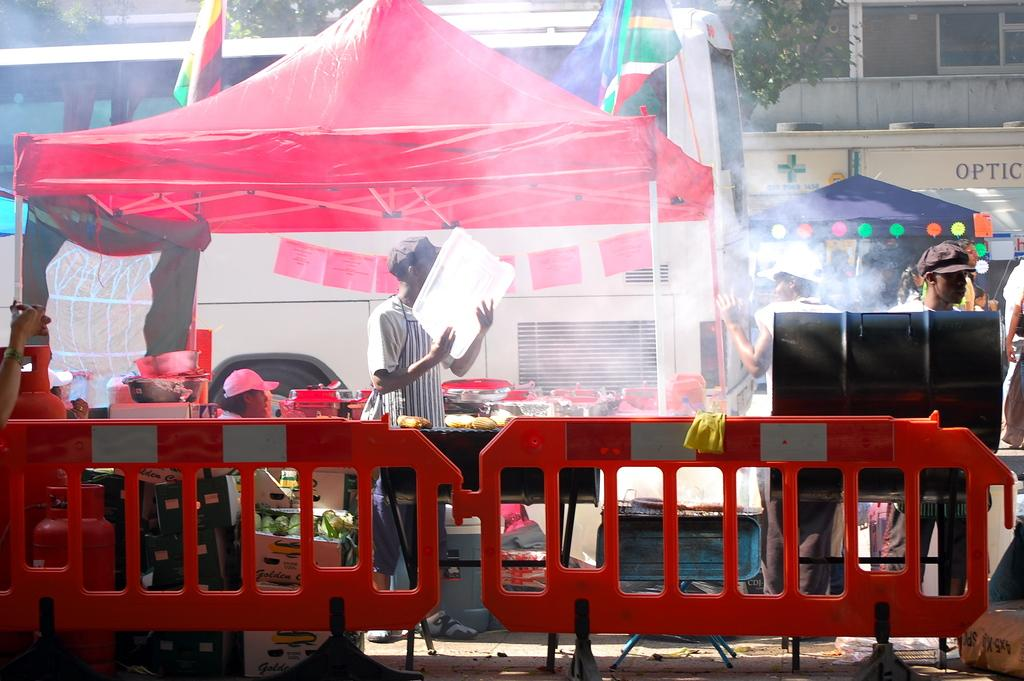What are the people in the image doing under the tents? The image shows people under tents, but their specific activity is not mentioned in the facts. What type of furniture is present in the image? There are tables in the image. What objects can be seen in addition to the tables? There are boxes and vessels in the image. What type of ring can be seen on the table in the image? There is no ring present on the table in the image. What type of humor is being displayed by the people in the image? The facts provided do not mention any humor or emotions of the people in the image. 